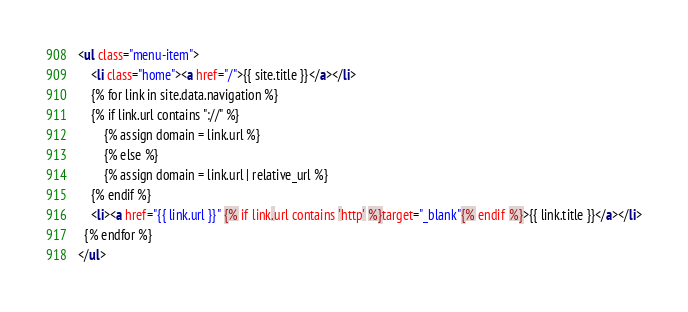Convert code to text. <code><loc_0><loc_0><loc_500><loc_500><_HTML_><ul class="menu-item">
	<li class="home"><a href="/">{{ site.title }}</a></li>
	{% for link in site.data.navigation %}
    {% if link.url contains "://" %}
        {% assign domain = link.url %}
        {% else %}
        {% assign domain = link.url | relative_url %}
    {% endif %}
    <li><a href="{{ link.url }}" {% if link.url contains 'http' %}target="_blank"{% endif %}>{{ link.title }}</a></li>
  {% endfor %}
</ul></code> 